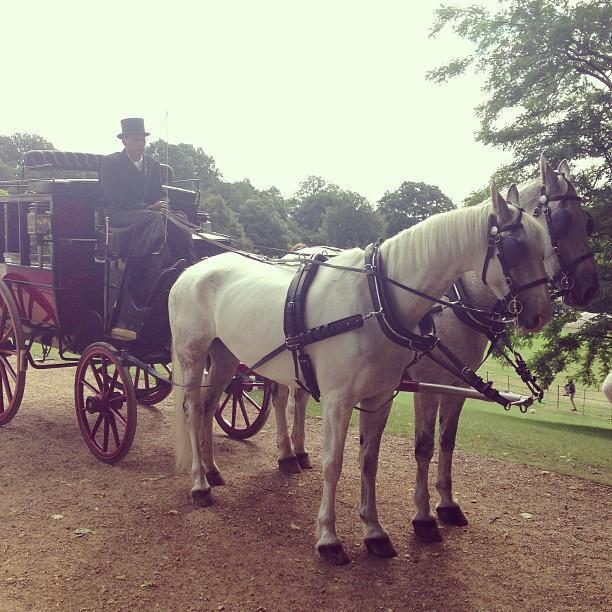How many horses are there?
Give a very brief answer. 2. 